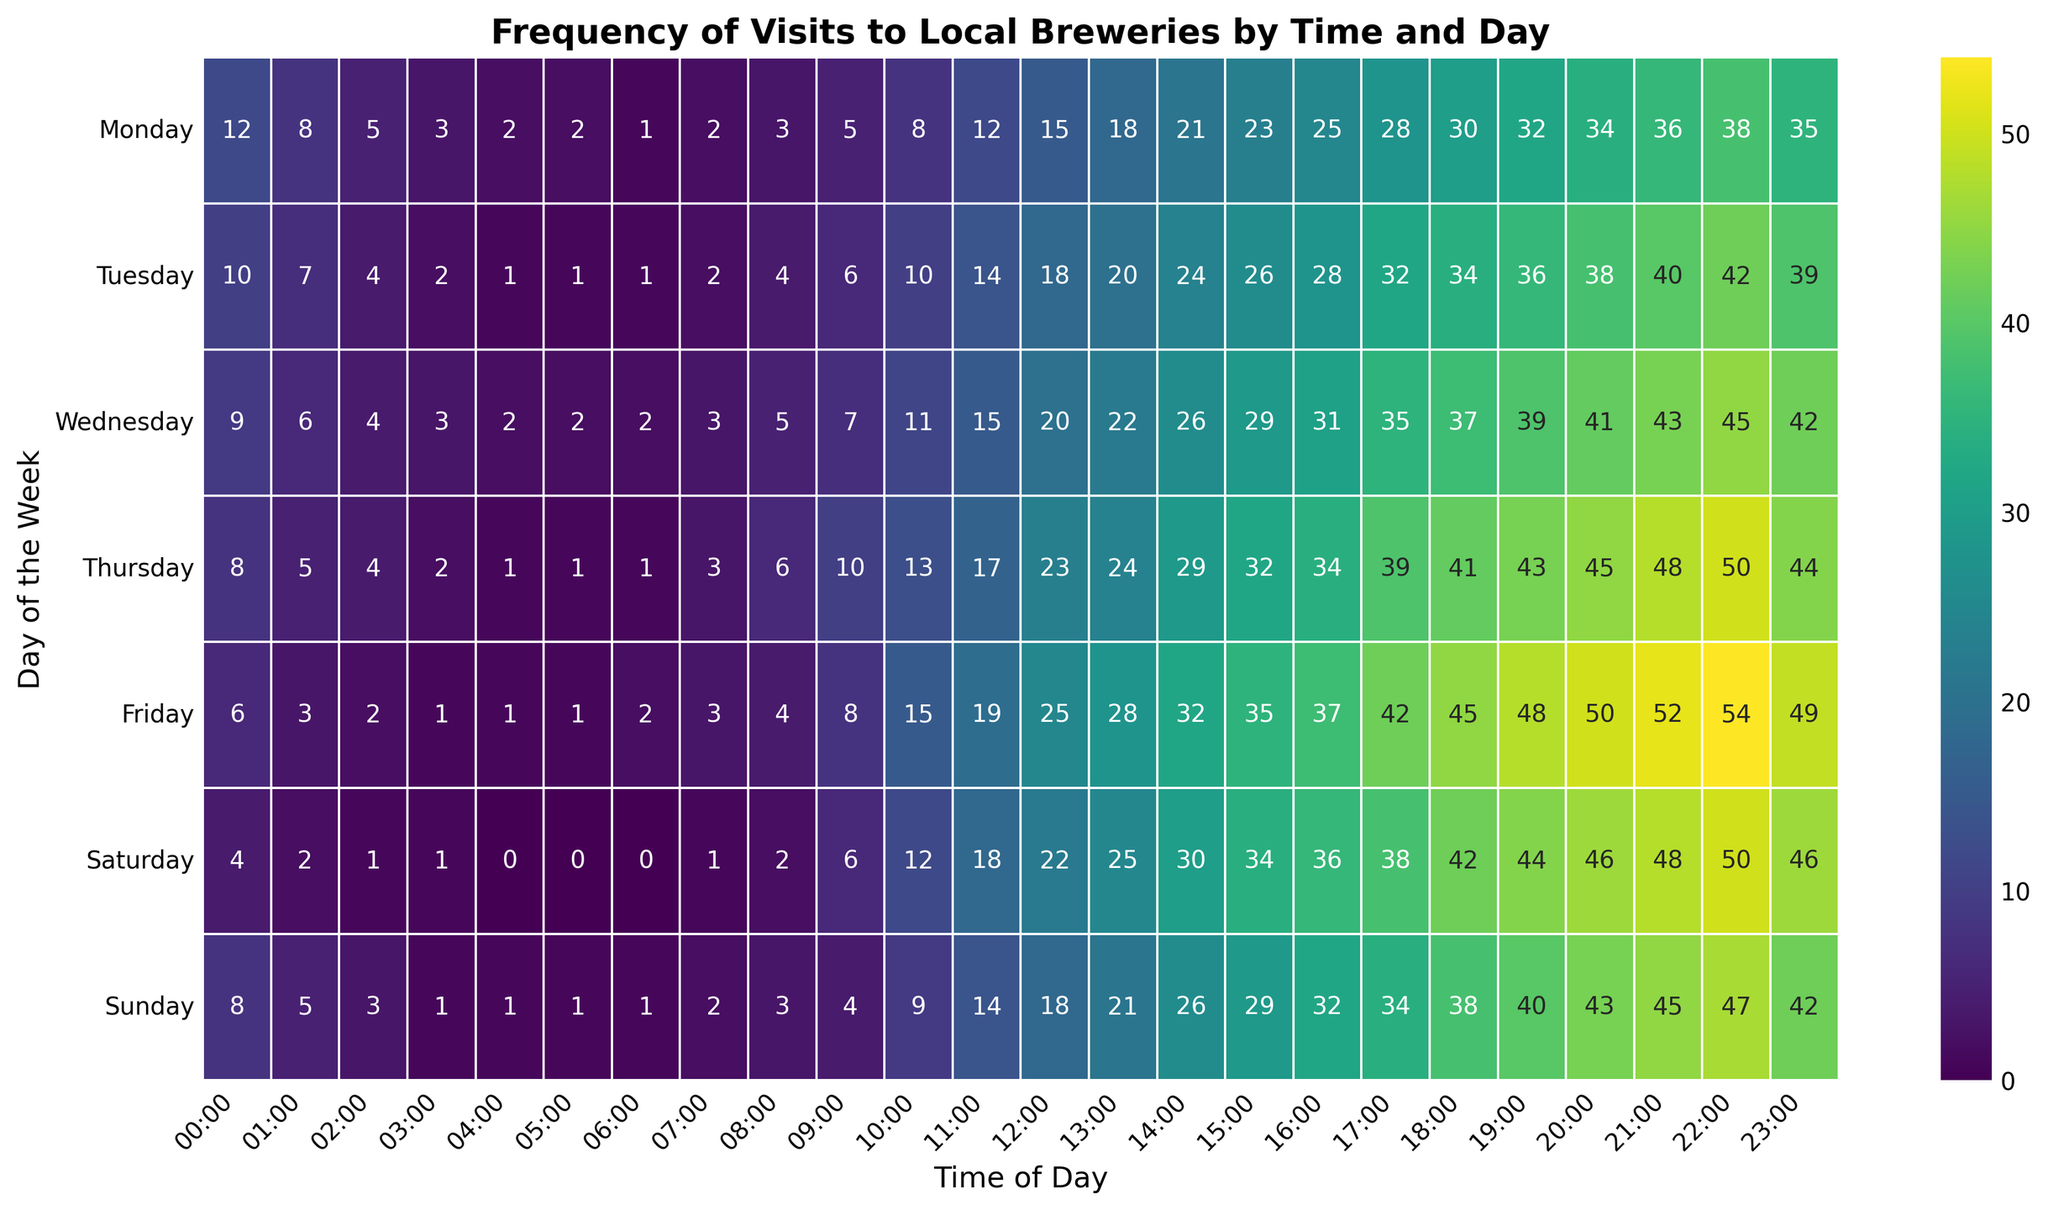What's the most popular time for brewery visits on Fridays? By looking at the heatmap, the darkest cell on Friday indicates the highest frequency of brewery visits. Visually, this occurs at 22:00 with the value 54.
Answer: 22:00 On which day and what time is the least traffic observed at breweries? The lightest cell on the heatmap signifies the lowest frequency of visits. The lightest cells are on Saturday and Sunday at 4:00, both with a value of 0.
Answer: Saturday and Sunday at 4:00 Which day shows the highest overall frequency in brewery visits during the evening (18:00 to 22:00)? Summing the values for every day between 18:00 and 22:00 and finding the highest total: Monday (170), Tuesday (192), Wednesday (205), Thursday (218), Friday (239), Saturday (228), Sunday (211). Friday has the highest total.
Answer: Friday On average, how many visits occur at 15:00 on weekdays (Monday to Friday)? Add the visits at 15:00 for each weekday and divide by the number of weekdays: (23 + 26 + 29 + 32 + 35) = 145, then 145/5 = 29.
Answer: 29 Compare the visit frequency at 12:00 on Wednesday and Sunday. Which has more visits and by how much? Find the values for 12:00 on Wednesday and Sunday: 20 and 18 respectively. The difference is 2.
Answer: Wednesday by 2 At what time does Saturday see the highest number of visits, and how does it compare to the same time on Thursday? The darkest cell on Saturday is at 21:00 with a value of 48. On Thursday at 21:00, the value is 48 as well. Both are equal.
Answer: 21:00, and they are equal How does the visit distribution between 9:00 and 11:00 on Tuesdays compare to the same period on Sundays? Add up the values for the given times and compare: Tuesday (6 + 10 + 14) = 30, Sunday (4 + 9 + 14) = 27. Tuesday is higher by 3.
Answer: Tuesday by 3 Which two consecutive hours on any day of the week show the largest increase in visits? Compare the increase in values for each pair of consecutive hours across all days. The largest increase is Thursday from 22:00 (50) to 23:00 (49), which is a decrease. The correct identification is Thursday from 21:00 (48) to 22:00 (50) which is an increase of 2.
Answer: Thursday 21:00 to 22:00 If you visit a brewery every Wednesday at 17:00 and every Sunday at 17:00, how many more people on average will you encounter on Wednesdays? The values for Wednesday and Sunday at 17:00 are 35 and 34 respectively. The difference is 1.
Answer: 1 